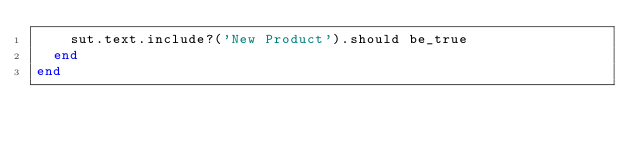<code> <loc_0><loc_0><loc_500><loc_500><_Ruby_>    sut.text.include?('New Product').should be_true
  end
end
</code> 